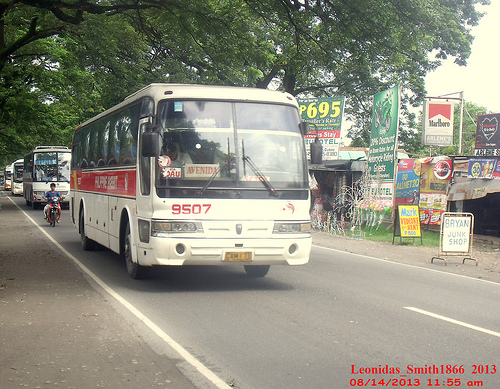<image>
Is the bus under the tree? Yes. The bus is positioned underneath the tree, with the tree above it in the vertical space. 